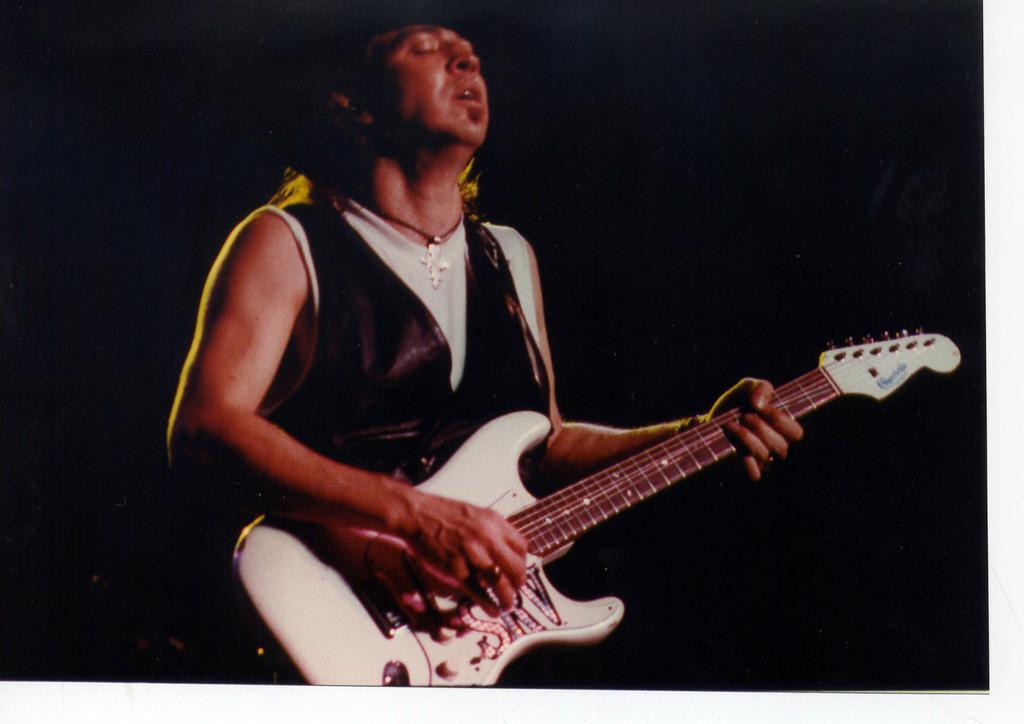How would you summarize this image in a sentence or two? In this picture there is a man who is standing at the center of the image, by holding the guitar in his hands and the color of the background is black in color. 